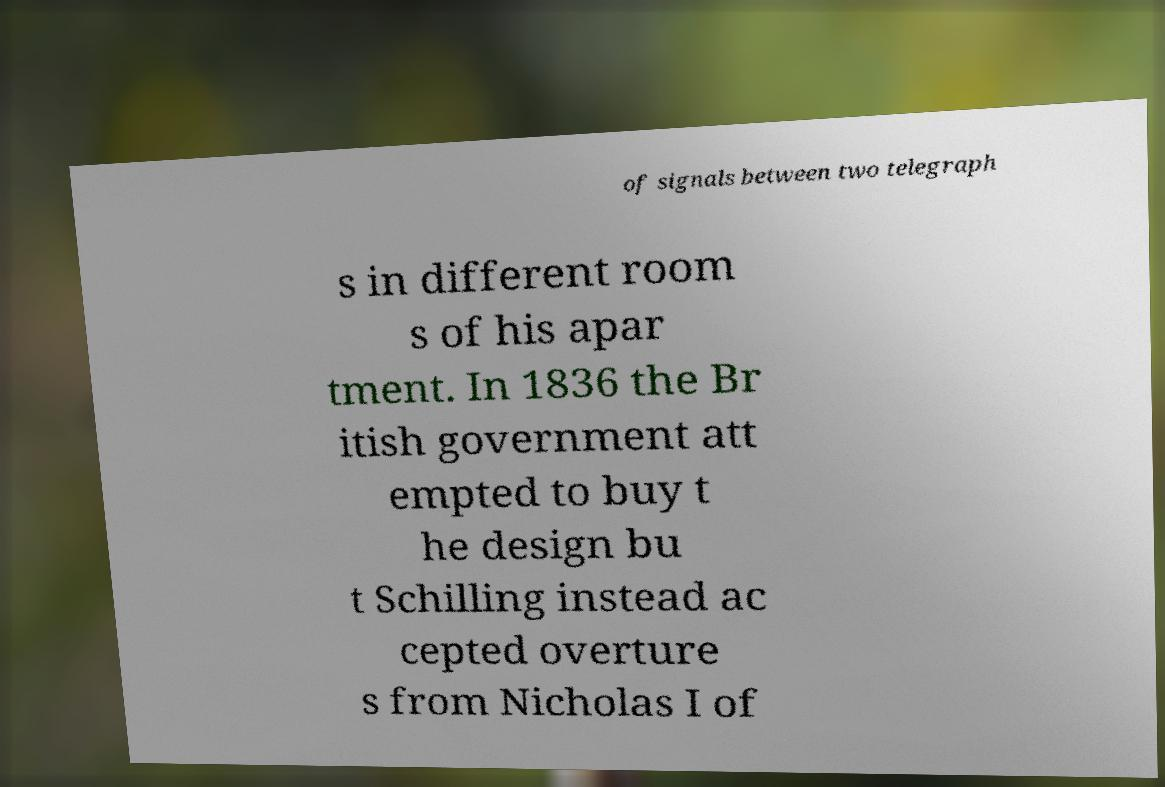Could you extract and type out the text from this image? of signals between two telegraph s in different room s of his apar tment. In 1836 the Br itish government att empted to buy t he design bu t Schilling instead ac cepted overture s from Nicholas I of 